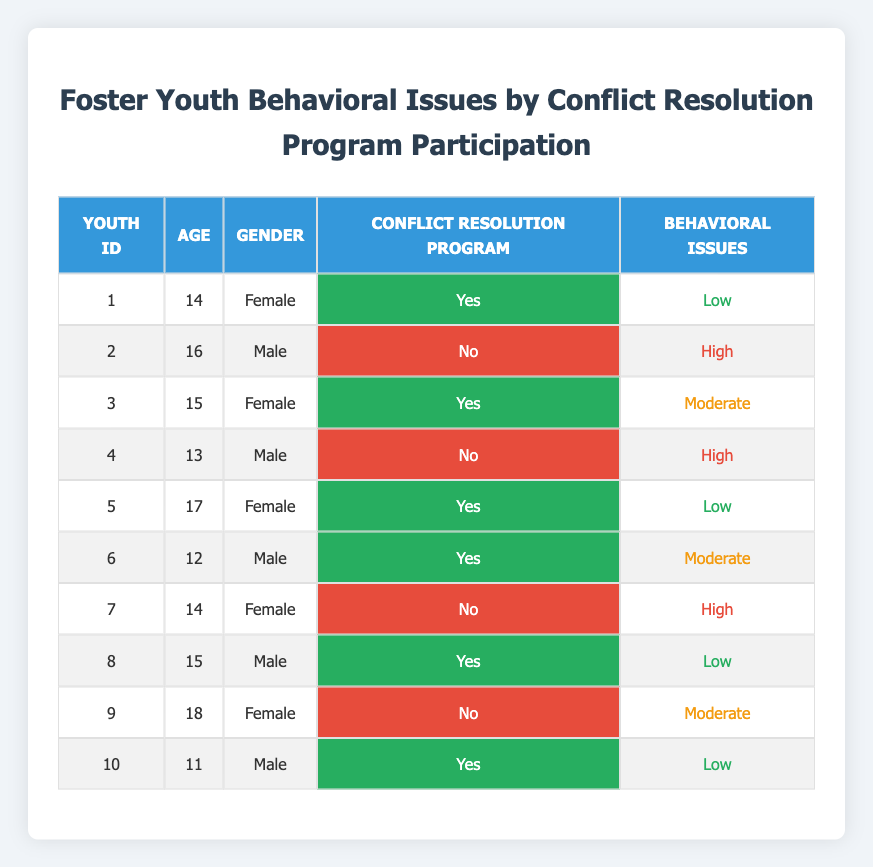What is the total number of youth who participated in the conflict resolution program? There are 5 entries in the table where the "Conflict Resolution Program" column is marked as "Yes." We can count these rows: rows 1, 3, 5, 6, and 10.
Answer: 5 How many youth have low behavioral issues and participated in the conflict resolution program? The table shows three youth with low behavioral issues who participated in the conflict resolution program: youth 1, 5, and 8.
Answer: 3 What percentage of youth who did not participate in the conflict resolution program have high behavioral issues? There are 4 youth who did not participate. Out of these, 3 have high behavioral issues (youth 2, 4, and 7). The percentage is (3/4) * 100 = 75%.
Answer: 75% Is there any male youth who participated in the conflict resolution program with moderate behavioral issues? Examining the table, youth 6 is a male who participated and has moderate behavioral issues. Therefore, the answer is yes.
Answer: Yes Which age group shows the highest incidence of high behavioral issues among those who did not participate in the program? Among the 4 youth who did not participate, youth ages 13 to 18 were analyzed. Youth 2 (16 years, high), youth 4 (13 years, high), and youth 7 (14 years, high) all show high behavioral issues. Therefore, with three occurrences, the age group with the highest incidence is 14 to 16.
Answer: 14 to 16 What is the median age of youth with moderate behavioral issues in the conflict resolution program? Youth with moderate issues in the program are youth 3 (15 years) and youth 6 (12 years). Listing these ages: 12 and 15. The median is the average of the two, which is (12+15)/2 = 13.5.
Answer: 13.5 How many total behavioral issues are noted in the youth who participated in the conflict resolution program? Youth in the program with behavioral issues are: 1 (low), 3 (moderate), 5 (low), 6 (moderate), and 10 (low). Adding these types: low=3 and moderate=2, giving a total of 5 behavioral issues recorded.
Answer: 5 What proportion of all youth in the table demonstrated high behavioral issues? Counting all youth in the table, there are 10 total. The youth demonstrating high behavioral issues are youth 2, 4, and 7. Thus, 3 out of 10 show high behavioral issues. The proportion is 3/10 = 0.3 or 30%.
Answer: 30% 